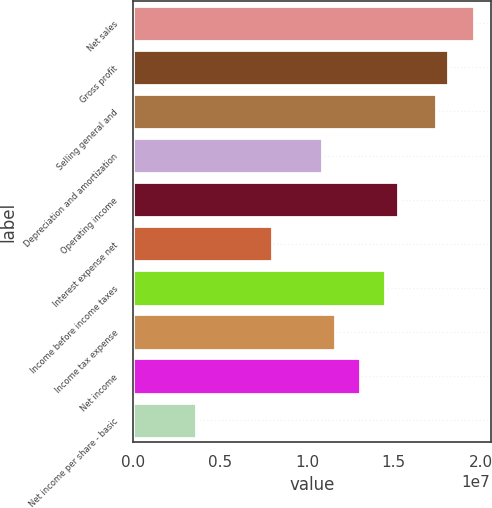Convert chart to OTSL. <chart><loc_0><loc_0><loc_500><loc_500><bar_chart><fcel>Net sales<fcel>Gross profit<fcel>Selling general and<fcel>Depreciation and amortization<fcel>Operating income<fcel>Interest expense net<fcel>Income before income taxes<fcel>Income tax expense<fcel>Net income<fcel>Net income per share - basic<nl><fcel>1.95922e+07<fcel>1.8141e+07<fcel>1.74153e+07<fcel>1.08846e+07<fcel>1.52384e+07<fcel>7.98202e+06<fcel>1.45128e+07<fcel>1.16102e+07<fcel>1.30615e+07<fcel>3.62819e+06<nl></chart> 